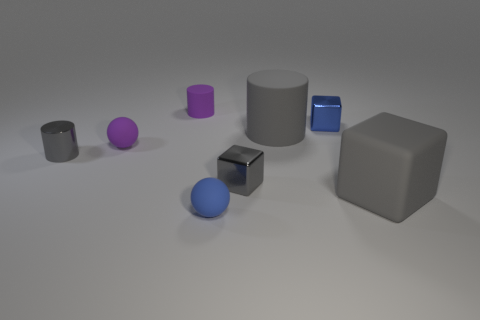There is a shiny cube that is the same color as the small metallic cylinder; what is its size?
Your answer should be very brief. Small. What is the material of the small cube that is the same color as the big block?
Give a very brief answer. Metal. Is there anything else that is the same size as the blue metal object?
Keep it short and to the point. Yes. Are there more tiny spheres right of the big rubber block than balls that are to the left of the tiny gray cylinder?
Your response must be concise. No. The small metal object that is behind the big gray matte object behind the gray object that is right of the blue metallic cube is what color?
Ensure brevity in your answer.  Blue. Is the color of the ball on the left side of the tiny blue matte thing the same as the big cube?
Offer a terse response. No. How many other objects are there of the same color as the big block?
Offer a very short reply. 3. What number of objects are either matte cubes or rubber objects?
Keep it short and to the point. 5. How many objects are either tiny blue rubber spheres or cylinders left of the blue matte ball?
Keep it short and to the point. 3. Is the tiny gray cylinder made of the same material as the small purple ball?
Keep it short and to the point. No. 